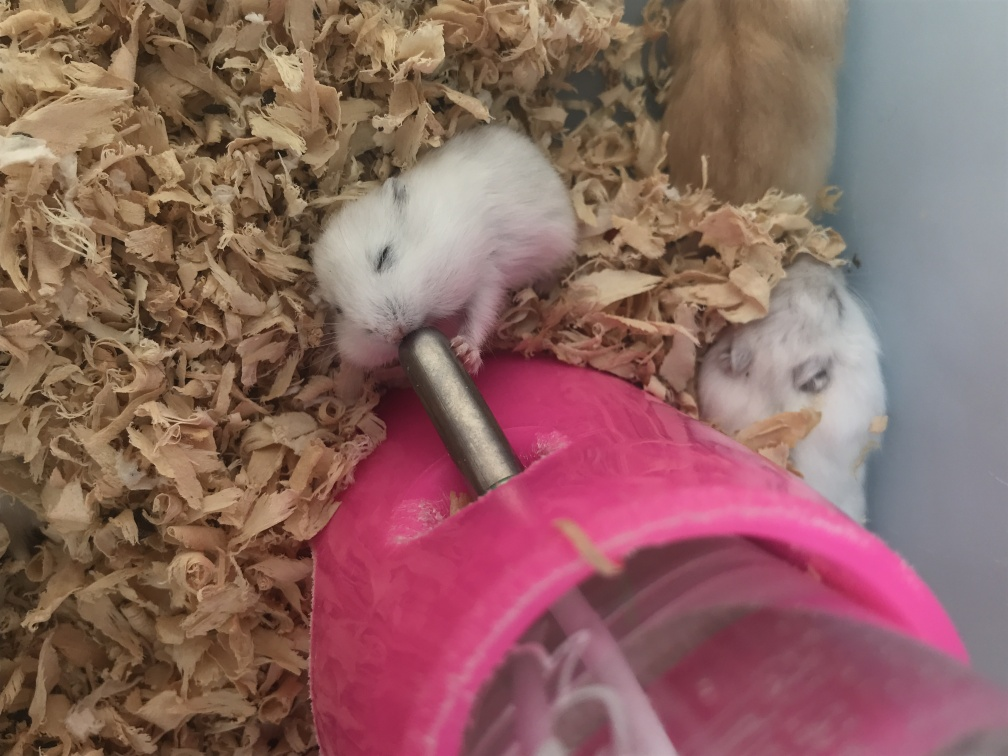Are there any quality issues with this image? The image has a soft focus, particularly around the hamsters and the water bottle, which may not have been intentional. Additionally, the lighting seems uneven, with the foreground being well-lit and the background remaining in shadow. The composition could be improved for better clarity. 